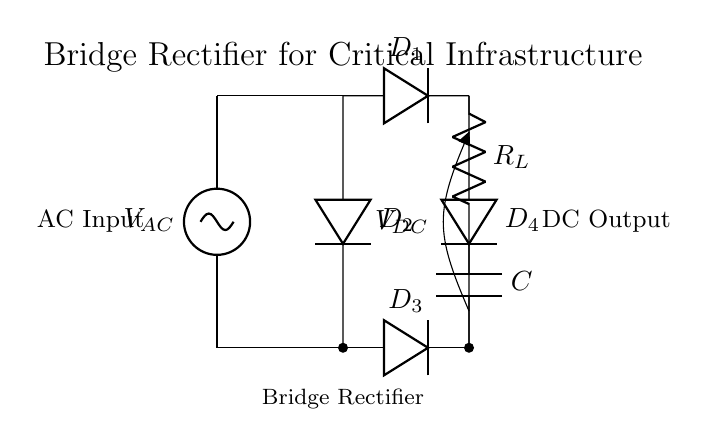What is the component type used for the load? The load component in the circuit is represented by a resistor, labeled as R_L, indicating it is meant to consume power from the output.
Answer: Resistor How many diodes are used in this bridge rectifier? The circuit diagram shows a total of four diodes labeled D1, D2, D3, and D4, which are essential for the rectification process in the bridge configuration.
Answer: Four diodes What is the purpose of the capacitor in this circuit? The capacitor, labeled C, serves to smooth the output voltage by reducing ripples, providing a more stable DC output voltage to the load.
Answer: Smoothing What is the type of input voltage in this circuit? The input voltage is represented by an AC source, indicated as V_AC, which means the circuit is designed to convert alternating current into direct current.
Answer: AC What could happen if one diode in the bridge rectifier fails? If one diode fails, the bridge rectifier will not function properly, potentially allowing only half of the AC waveform to pass through, leading to increased ripple and reduced DC voltage at the output.
Answer: Increased ripple What is the output voltage type after rectification? The output voltage, labeled as V_DC, is direct current (DC) which indicates that the rectification process has effectively converted the input AC voltage to DC voltage for the load.
Answer: DC What is the significance of having a bridge configuration instead of a single diode? The bridge configuration allows for full-wave rectification, which is more efficient than half-wave rectification, as it utilizes both halves of the AC waveform, resulting in higher average output voltage and better performance.
Answer: Full-wave rectification 